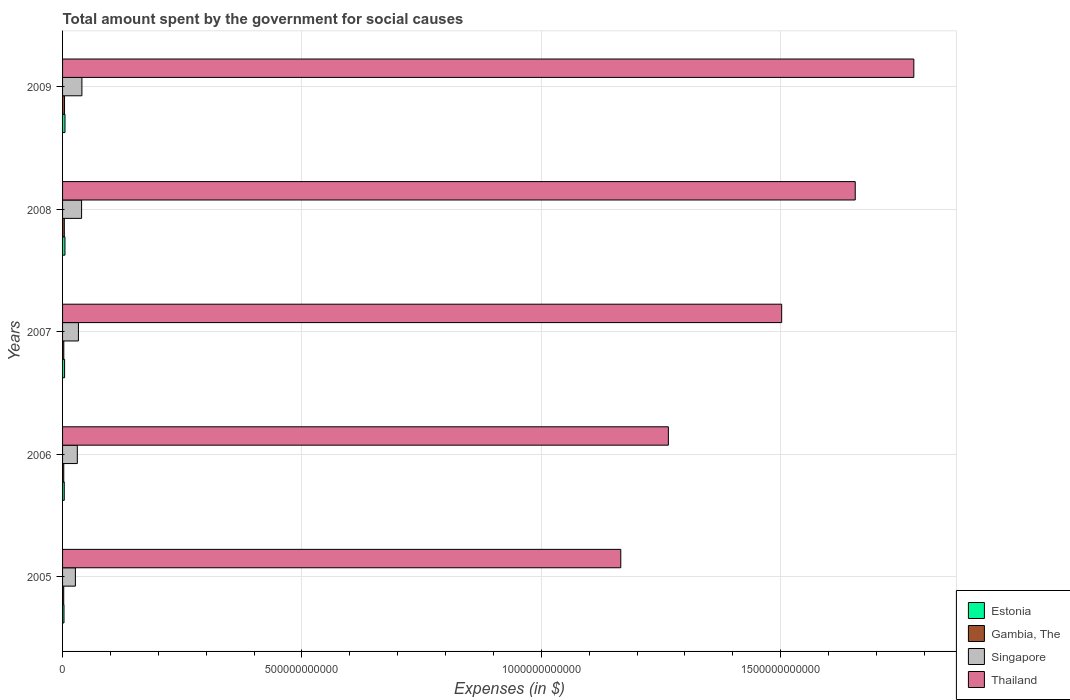How many groups of bars are there?
Ensure brevity in your answer.  5. Are the number of bars per tick equal to the number of legend labels?
Your answer should be compact. Yes. How many bars are there on the 3rd tick from the bottom?
Make the answer very short. 4. What is the label of the 1st group of bars from the top?
Provide a short and direct response. 2009. What is the amount spent for social causes by the government in Thailand in 2005?
Make the answer very short. 1.17e+12. Across all years, what is the maximum amount spent for social causes by the government in Estonia?
Provide a short and direct response. 5.04e+09. Across all years, what is the minimum amount spent for social causes by the government in Singapore?
Your answer should be very brief. 2.68e+1. In which year was the amount spent for social causes by the government in Thailand maximum?
Your answer should be very brief. 2009. In which year was the amount spent for social causes by the government in Estonia minimum?
Provide a short and direct response. 2005. What is the total amount spent for social causes by the government in Thailand in the graph?
Your answer should be compact. 7.37e+12. What is the difference between the amount spent for social causes by the government in Singapore in 2006 and that in 2009?
Ensure brevity in your answer.  -9.56e+09. What is the difference between the amount spent for social causes by the government in Singapore in 2005 and the amount spent for social causes by the government in Thailand in 2008?
Offer a very short reply. -1.63e+12. What is the average amount spent for social causes by the government in Gambia, The per year?
Ensure brevity in your answer.  3.06e+09. In the year 2005, what is the difference between the amount spent for social causes by the government in Singapore and amount spent for social causes by the government in Thailand?
Keep it short and to the point. -1.14e+12. In how many years, is the amount spent for social causes by the government in Singapore greater than 1700000000000 $?
Make the answer very short. 0. What is the ratio of the amount spent for social causes by the government in Singapore in 2008 to that in 2009?
Give a very brief answer. 0.98. What is the difference between the highest and the second highest amount spent for social causes by the government in Thailand?
Provide a short and direct response. 1.22e+11. What is the difference between the highest and the lowest amount spent for social causes by the government in Gambia, The?
Provide a succinct answer. 1.70e+09. In how many years, is the amount spent for social causes by the government in Gambia, The greater than the average amount spent for social causes by the government in Gambia, The taken over all years?
Your answer should be compact. 2. Is it the case that in every year, the sum of the amount spent for social causes by the government in Estonia and amount spent for social causes by the government in Singapore is greater than the sum of amount spent for social causes by the government in Gambia, The and amount spent for social causes by the government in Thailand?
Your response must be concise. No. What does the 1st bar from the top in 2009 represents?
Provide a succinct answer. Thailand. What does the 4th bar from the bottom in 2009 represents?
Ensure brevity in your answer.  Thailand. How many bars are there?
Your answer should be compact. 20. Are all the bars in the graph horizontal?
Ensure brevity in your answer.  Yes. What is the difference between two consecutive major ticks on the X-axis?
Offer a terse response. 5.00e+11. Are the values on the major ticks of X-axis written in scientific E-notation?
Give a very brief answer. No. Does the graph contain grids?
Offer a very short reply. Yes. How many legend labels are there?
Offer a very short reply. 4. How are the legend labels stacked?
Your answer should be very brief. Vertical. What is the title of the graph?
Offer a very short reply. Total amount spent by the government for social causes. What is the label or title of the X-axis?
Give a very brief answer. Expenses (in $). What is the Expenses (in $) of Estonia in 2005?
Provide a short and direct response. 2.99e+09. What is the Expenses (in $) of Gambia, The in 2005?
Offer a terse response. 2.42e+09. What is the Expenses (in $) in Singapore in 2005?
Ensure brevity in your answer.  2.68e+1. What is the Expenses (in $) in Thailand in 2005?
Make the answer very short. 1.17e+12. What is the Expenses (in $) of Estonia in 2006?
Your response must be concise. 3.56e+09. What is the Expenses (in $) in Gambia, The in 2006?
Ensure brevity in your answer.  2.52e+09. What is the Expenses (in $) of Singapore in 2006?
Your answer should be compact. 3.08e+1. What is the Expenses (in $) in Thailand in 2006?
Offer a very short reply. 1.27e+12. What is the Expenses (in $) in Estonia in 2007?
Offer a very short reply. 4.25e+09. What is the Expenses (in $) in Gambia, The in 2007?
Keep it short and to the point. 2.58e+09. What is the Expenses (in $) in Singapore in 2007?
Make the answer very short. 3.31e+1. What is the Expenses (in $) in Thailand in 2007?
Offer a very short reply. 1.50e+12. What is the Expenses (in $) in Estonia in 2008?
Ensure brevity in your answer.  5.00e+09. What is the Expenses (in $) in Gambia, The in 2008?
Offer a terse response. 3.65e+09. What is the Expenses (in $) of Singapore in 2008?
Your answer should be compact. 3.97e+1. What is the Expenses (in $) of Thailand in 2008?
Make the answer very short. 1.66e+12. What is the Expenses (in $) in Estonia in 2009?
Keep it short and to the point. 5.04e+09. What is the Expenses (in $) of Gambia, The in 2009?
Make the answer very short. 4.12e+09. What is the Expenses (in $) in Singapore in 2009?
Give a very brief answer. 4.04e+1. What is the Expenses (in $) in Thailand in 2009?
Your answer should be very brief. 1.78e+12. Across all years, what is the maximum Expenses (in $) in Estonia?
Keep it short and to the point. 5.04e+09. Across all years, what is the maximum Expenses (in $) of Gambia, The?
Offer a terse response. 4.12e+09. Across all years, what is the maximum Expenses (in $) in Singapore?
Your answer should be very brief. 4.04e+1. Across all years, what is the maximum Expenses (in $) of Thailand?
Offer a very short reply. 1.78e+12. Across all years, what is the minimum Expenses (in $) of Estonia?
Your response must be concise. 2.99e+09. Across all years, what is the minimum Expenses (in $) of Gambia, The?
Your answer should be very brief. 2.42e+09. Across all years, what is the minimum Expenses (in $) of Singapore?
Offer a very short reply. 2.68e+1. Across all years, what is the minimum Expenses (in $) of Thailand?
Give a very brief answer. 1.17e+12. What is the total Expenses (in $) of Estonia in the graph?
Ensure brevity in your answer.  2.08e+1. What is the total Expenses (in $) in Gambia, The in the graph?
Provide a succinct answer. 1.53e+1. What is the total Expenses (in $) in Singapore in the graph?
Ensure brevity in your answer.  1.71e+11. What is the total Expenses (in $) in Thailand in the graph?
Provide a succinct answer. 7.37e+12. What is the difference between the Expenses (in $) in Estonia in 2005 and that in 2006?
Your answer should be compact. -5.69e+08. What is the difference between the Expenses (in $) of Gambia, The in 2005 and that in 2006?
Provide a succinct answer. -9.60e+07. What is the difference between the Expenses (in $) in Singapore in 2005 and that in 2006?
Make the answer very short. -4.04e+09. What is the difference between the Expenses (in $) of Thailand in 2005 and that in 2006?
Your answer should be very brief. -9.94e+1. What is the difference between the Expenses (in $) in Estonia in 2005 and that in 2007?
Make the answer very short. -1.26e+09. What is the difference between the Expenses (in $) of Gambia, The in 2005 and that in 2007?
Keep it short and to the point. -1.65e+08. What is the difference between the Expenses (in $) of Singapore in 2005 and that in 2007?
Your answer should be very brief. -6.34e+09. What is the difference between the Expenses (in $) of Thailand in 2005 and that in 2007?
Ensure brevity in your answer.  -3.36e+11. What is the difference between the Expenses (in $) in Estonia in 2005 and that in 2008?
Your answer should be very brief. -2.01e+09. What is the difference between the Expenses (in $) in Gambia, The in 2005 and that in 2008?
Offer a very short reply. -1.23e+09. What is the difference between the Expenses (in $) in Singapore in 2005 and that in 2008?
Provide a succinct answer. -1.29e+1. What is the difference between the Expenses (in $) of Thailand in 2005 and that in 2008?
Make the answer very short. -4.90e+11. What is the difference between the Expenses (in $) in Estonia in 2005 and that in 2009?
Provide a succinct answer. -2.05e+09. What is the difference between the Expenses (in $) in Gambia, The in 2005 and that in 2009?
Offer a terse response. -1.70e+09. What is the difference between the Expenses (in $) of Singapore in 2005 and that in 2009?
Provide a short and direct response. -1.36e+1. What is the difference between the Expenses (in $) of Thailand in 2005 and that in 2009?
Provide a short and direct response. -6.12e+11. What is the difference between the Expenses (in $) of Estonia in 2006 and that in 2007?
Give a very brief answer. -6.92e+08. What is the difference between the Expenses (in $) in Gambia, The in 2006 and that in 2007?
Your answer should be very brief. -6.88e+07. What is the difference between the Expenses (in $) in Singapore in 2006 and that in 2007?
Give a very brief answer. -2.30e+09. What is the difference between the Expenses (in $) of Thailand in 2006 and that in 2007?
Make the answer very short. -2.37e+11. What is the difference between the Expenses (in $) of Estonia in 2006 and that in 2008?
Give a very brief answer. -1.44e+09. What is the difference between the Expenses (in $) in Gambia, The in 2006 and that in 2008?
Give a very brief answer. -1.13e+09. What is the difference between the Expenses (in $) of Singapore in 2006 and that in 2008?
Your response must be concise. -8.90e+09. What is the difference between the Expenses (in $) of Thailand in 2006 and that in 2008?
Provide a succinct answer. -3.90e+11. What is the difference between the Expenses (in $) in Estonia in 2006 and that in 2009?
Your response must be concise. -1.48e+09. What is the difference between the Expenses (in $) in Gambia, The in 2006 and that in 2009?
Your answer should be compact. -1.60e+09. What is the difference between the Expenses (in $) of Singapore in 2006 and that in 2009?
Your answer should be compact. -9.56e+09. What is the difference between the Expenses (in $) of Thailand in 2006 and that in 2009?
Ensure brevity in your answer.  -5.13e+11. What is the difference between the Expenses (in $) of Estonia in 2007 and that in 2008?
Give a very brief answer. -7.51e+08. What is the difference between the Expenses (in $) in Gambia, The in 2007 and that in 2008?
Provide a succinct answer. -1.07e+09. What is the difference between the Expenses (in $) of Singapore in 2007 and that in 2008?
Keep it short and to the point. -6.60e+09. What is the difference between the Expenses (in $) of Thailand in 2007 and that in 2008?
Offer a terse response. -1.54e+11. What is the difference between the Expenses (in $) in Estonia in 2007 and that in 2009?
Give a very brief answer. -7.90e+08. What is the difference between the Expenses (in $) of Gambia, The in 2007 and that in 2009?
Your answer should be very brief. -1.53e+09. What is the difference between the Expenses (in $) of Singapore in 2007 and that in 2009?
Provide a succinct answer. -7.26e+09. What is the difference between the Expenses (in $) of Thailand in 2007 and that in 2009?
Offer a very short reply. -2.76e+11. What is the difference between the Expenses (in $) of Estonia in 2008 and that in 2009?
Offer a very short reply. -3.87e+07. What is the difference between the Expenses (in $) of Gambia, The in 2008 and that in 2009?
Ensure brevity in your answer.  -4.65e+08. What is the difference between the Expenses (in $) of Singapore in 2008 and that in 2009?
Give a very brief answer. -6.59e+08. What is the difference between the Expenses (in $) in Thailand in 2008 and that in 2009?
Your response must be concise. -1.22e+11. What is the difference between the Expenses (in $) in Estonia in 2005 and the Expenses (in $) in Gambia, The in 2006?
Make the answer very short. 4.75e+08. What is the difference between the Expenses (in $) of Estonia in 2005 and the Expenses (in $) of Singapore in 2006?
Your response must be concise. -2.78e+1. What is the difference between the Expenses (in $) of Estonia in 2005 and the Expenses (in $) of Thailand in 2006?
Give a very brief answer. -1.26e+12. What is the difference between the Expenses (in $) in Gambia, The in 2005 and the Expenses (in $) in Singapore in 2006?
Offer a very short reply. -2.84e+1. What is the difference between the Expenses (in $) of Gambia, The in 2005 and the Expenses (in $) of Thailand in 2006?
Your answer should be compact. -1.26e+12. What is the difference between the Expenses (in $) in Singapore in 2005 and the Expenses (in $) in Thailand in 2006?
Provide a succinct answer. -1.24e+12. What is the difference between the Expenses (in $) in Estonia in 2005 and the Expenses (in $) in Gambia, The in 2007?
Your response must be concise. 4.06e+08. What is the difference between the Expenses (in $) of Estonia in 2005 and the Expenses (in $) of Singapore in 2007?
Provide a short and direct response. -3.01e+1. What is the difference between the Expenses (in $) of Estonia in 2005 and the Expenses (in $) of Thailand in 2007?
Make the answer very short. -1.50e+12. What is the difference between the Expenses (in $) of Gambia, The in 2005 and the Expenses (in $) of Singapore in 2007?
Offer a very short reply. -3.07e+1. What is the difference between the Expenses (in $) in Gambia, The in 2005 and the Expenses (in $) in Thailand in 2007?
Make the answer very short. -1.50e+12. What is the difference between the Expenses (in $) in Singapore in 2005 and the Expenses (in $) in Thailand in 2007?
Provide a succinct answer. -1.48e+12. What is the difference between the Expenses (in $) in Estonia in 2005 and the Expenses (in $) in Gambia, The in 2008?
Your response must be concise. -6.60e+08. What is the difference between the Expenses (in $) in Estonia in 2005 and the Expenses (in $) in Singapore in 2008?
Make the answer very short. -3.67e+1. What is the difference between the Expenses (in $) of Estonia in 2005 and the Expenses (in $) of Thailand in 2008?
Provide a succinct answer. -1.65e+12. What is the difference between the Expenses (in $) in Gambia, The in 2005 and the Expenses (in $) in Singapore in 2008?
Provide a short and direct response. -3.73e+1. What is the difference between the Expenses (in $) of Gambia, The in 2005 and the Expenses (in $) of Thailand in 2008?
Your response must be concise. -1.65e+12. What is the difference between the Expenses (in $) in Singapore in 2005 and the Expenses (in $) in Thailand in 2008?
Your answer should be very brief. -1.63e+12. What is the difference between the Expenses (in $) in Estonia in 2005 and the Expenses (in $) in Gambia, The in 2009?
Make the answer very short. -1.12e+09. What is the difference between the Expenses (in $) in Estonia in 2005 and the Expenses (in $) in Singapore in 2009?
Your response must be concise. -3.74e+1. What is the difference between the Expenses (in $) of Estonia in 2005 and the Expenses (in $) of Thailand in 2009?
Make the answer very short. -1.78e+12. What is the difference between the Expenses (in $) of Gambia, The in 2005 and the Expenses (in $) of Singapore in 2009?
Your answer should be very brief. -3.80e+1. What is the difference between the Expenses (in $) in Gambia, The in 2005 and the Expenses (in $) in Thailand in 2009?
Offer a very short reply. -1.78e+12. What is the difference between the Expenses (in $) of Singapore in 2005 and the Expenses (in $) of Thailand in 2009?
Provide a short and direct response. -1.75e+12. What is the difference between the Expenses (in $) of Estonia in 2006 and the Expenses (in $) of Gambia, The in 2007?
Make the answer very short. 9.75e+08. What is the difference between the Expenses (in $) in Estonia in 2006 and the Expenses (in $) in Singapore in 2007?
Keep it short and to the point. -2.96e+1. What is the difference between the Expenses (in $) in Estonia in 2006 and the Expenses (in $) in Thailand in 2007?
Keep it short and to the point. -1.50e+12. What is the difference between the Expenses (in $) in Gambia, The in 2006 and the Expenses (in $) in Singapore in 2007?
Your answer should be compact. -3.06e+1. What is the difference between the Expenses (in $) of Gambia, The in 2006 and the Expenses (in $) of Thailand in 2007?
Make the answer very short. -1.50e+12. What is the difference between the Expenses (in $) of Singapore in 2006 and the Expenses (in $) of Thailand in 2007?
Offer a very short reply. -1.47e+12. What is the difference between the Expenses (in $) of Estonia in 2006 and the Expenses (in $) of Gambia, The in 2008?
Your answer should be compact. -9.08e+07. What is the difference between the Expenses (in $) of Estonia in 2006 and the Expenses (in $) of Singapore in 2008?
Keep it short and to the point. -3.62e+1. What is the difference between the Expenses (in $) of Estonia in 2006 and the Expenses (in $) of Thailand in 2008?
Your answer should be compact. -1.65e+12. What is the difference between the Expenses (in $) of Gambia, The in 2006 and the Expenses (in $) of Singapore in 2008?
Offer a terse response. -3.72e+1. What is the difference between the Expenses (in $) in Gambia, The in 2006 and the Expenses (in $) in Thailand in 2008?
Your answer should be compact. -1.65e+12. What is the difference between the Expenses (in $) in Singapore in 2006 and the Expenses (in $) in Thailand in 2008?
Offer a very short reply. -1.63e+12. What is the difference between the Expenses (in $) in Estonia in 2006 and the Expenses (in $) in Gambia, The in 2009?
Provide a succinct answer. -5.56e+08. What is the difference between the Expenses (in $) in Estonia in 2006 and the Expenses (in $) in Singapore in 2009?
Provide a short and direct response. -3.68e+1. What is the difference between the Expenses (in $) of Estonia in 2006 and the Expenses (in $) of Thailand in 2009?
Offer a terse response. -1.77e+12. What is the difference between the Expenses (in $) of Gambia, The in 2006 and the Expenses (in $) of Singapore in 2009?
Give a very brief answer. -3.79e+1. What is the difference between the Expenses (in $) of Gambia, The in 2006 and the Expenses (in $) of Thailand in 2009?
Offer a terse response. -1.78e+12. What is the difference between the Expenses (in $) of Singapore in 2006 and the Expenses (in $) of Thailand in 2009?
Your answer should be compact. -1.75e+12. What is the difference between the Expenses (in $) in Estonia in 2007 and the Expenses (in $) in Gambia, The in 2008?
Make the answer very short. 6.01e+08. What is the difference between the Expenses (in $) of Estonia in 2007 and the Expenses (in $) of Singapore in 2008?
Your answer should be very brief. -3.55e+1. What is the difference between the Expenses (in $) of Estonia in 2007 and the Expenses (in $) of Thailand in 2008?
Provide a short and direct response. -1.65e+12. What is the difference between the Expenses (in $) in Gambia, The in 2007 and the Expenses (in $) in Singapore in 2008?
Offer a very short reply. -3.72e+1. What is the difference between the Expenses (in $) in Gambia, The in 2007 and the Expenses (in $) in Thailand in 2008?
Make the answer very short. -1.65e+12. What is the difference between the Expenses (in $) in Singapore in 2007 and the Expenses (in $) in Thailand in 2008?
Provide a succinct answer. -1.62e+12. What is the difference between the Expenses (in $) of Estonia in 2007 and the Expenses (in $) of Gambia, The in 2009?
Ensure brevity in your answer.  1.36e+08. What is the difference between the Expenses (in $) in Estonia in 2007 and the Expenses (in $) in Singapore in 2009?
Your answer should be compact. -3.61e+1. What is the difference between the Expenses (in $) in Estonia in 2007 and the Expenses (in $) in Thailand in 2009?
Your response must be concise. -1.77e+12. What is the difference between the Expenses (in $) of Gambia, The in 2007 and the Expenses (in $) of Singapore in 2009?
Keep it short and to the point. -3.78e+1. What is the difference between the Expenses (in $) of Gambia, The in 2007 and the Expenses (in $) of Thailand in 2009?
Your answer should be compact. -1.78e+12. What is the difference between the Expenses (in $) of Singapore in 2007 and the Expenses (in $) of Thailand in 2009?
Provide a short and direct response. -1.75e+12. What is the difference between the Expenses (in $) of Estonia in 2008 and the Expenses (in $) of Gambia, The in 2009?
Your response must be concise. 8.87e+08. What is the difference between the Expenses (in $) of Estonia in 2008 and the Expenses (in $) of Singapore in 2009?
Offer a very short reply. -3.54e+1. What is the difference between the Expenses (in $) in Estonia in 2008 and the Expenses (in $) in Thailand in 2009?
Your answer should be very brief. -1.77e+12. What is the difference between the Expenses (in $) in Gambia, The in 2008 and the Expenses (in $) in Singapore in 2009?
Your response must be concise. -3.67e+1. What is the difference between the Expenses (in $) in Gambia, The in 2008 and the Expenses (in $) in Thailand in 2009?
Ensure brevity in your answer.  -1.77e+12. What is the difference between the Expenses (in $) of Singapore in 2008 and the Expenses (in $) of Thailand in 2009?
Ensure brevity in your answer.  -1.74e+12. What is the average Expenses (in $) in Estonia per year?
Your response must be concise. 4.17e+09. What is the average Expenses (in $) of Gambia, The per year?
Offer a very short reply. 3.06e+09. What is the average Expenses (in $) in Singapore per year?
Provide a succinct answer. 3.42e+1. What is the average Expenses (in $) of Thailand per year?
Offer a very short reply. 1.47e+12. In the year 2005, what is the difference between the Expenses (in $) of Estonia and Expenses (in $) of Gambia, The?
Your answer should be very brief. 5.71e+08. In the year 2005, what is the difference between the Expenses (in $) of Estonia and Expenses (in $) of Singapore?
Give a very brief answer. -2.38e+1. In the year 2005, what is the difference between the Expenses (in $) of Estonia and Expenses (in $) of Thailand?
Give a very brief answer. -1.16e+12. In the year 2005, what is the difference between the Expenses (in $) of Gambia, The and Expenses (in $) of Singapore?
Offer a very short reply. -2.44e+1. In the year 2005, what is the difference between the Expenses (in $) of Gambia, The and Expenses (in $) of Thailand?
Ensure brevity in your answer.  -1.16e+12. In the year 2005, what is the difference between the Expenses (in $) of Singapore and Expenses (in $) of Thailand?
Your answer should be compact. -1.14e+12. In the year 2006, what is the difference between the Expenses (in $) of Estonia and Expenses (in $) of Gambia, The?
Your answer should be compact. 1.04e+09. In the year 2006, what is the difference between the Expenses (in $) in Estonia and Expenses (in $) in Singapore?
Offer a very short reply. -2.73e+1. In the year 2006, what is the difference between the Expenses (in $) in Estonia and Expenses (in $) in Thailand?
Keep it short and to the point. -1.26e+12. In the year 2006, what is the difference between the Expenses (in $) in Gambia, The and Expenses (in $) in Singapore?
Provide a short and direct response. -2.83e+1. In the year 2006, what is the difference between the Expenses (in $) in Gambia, The and Expenses (in $) in Thailand?
Give a very brief answer. -1.26e+12. In the year 2006, what is the difference between the Expenses (in $) of Singapore and Expenses (in $) of Thailand?
Provide a succinct answer. -1.23e+12. In the year 2007, what is the difference between the Expenses (in $) of Estonia and Expenses (in $) of Gambia, The?
Ensure brevity in your answer.  1.67e+09. In the year 2007, what is the difference between the Expenses (in $) in Estonia and Expenses (in $) in Singapore?
Your response must be concise. -2.89e+1. In the year 2007, what is the difference between the Expenses (in $) of Estonia and Expenses (in $) of Thailand?
Provide a short and direct response. -1.50e+12. In the year 2007, what is the difference between the Expenses (in $) of Gambia, The and Expenses (in $) of Singapore?
Provide a short and direct response. -3.05e+1. In the year 2007, what is the difference between the Expenses (in $) in Gambia, The and Expenses (in $) in Thailand?
Keep it short and to the point. -1.50e+12. In the year 2007, what is the difference between the Expenses (in $) in Singapore and Expenses (in $) in Thailand?
Give a very brief answer. -1.47e+12. In the year 2008, what is the difference between the Expenses (in $) in Estonia and Expenses (in $) in Gambia, The?
Give a very brief answer. 1.35e+09. In the year 2008, what is the difference between the Expenses (in $) of Estonia and Expenses (in $) of Singapore?
Offer a very short reply. -3.47e+1. In the year 2008, what is the difference between the Expenses (in $) of Estonia and Expenses (in $) of Thailand?
Offer a very short reply. -1.65e+12. In the year 2008, what is the difference between the Expenses (in $) of Gambia, The and Expenses (in $) of Singapore?
Ensure brevity in your answer.  -3.61e+1. In the year 2008, what is the difference between the Expenses (in $) in Gambia, The and Expenses (in $) in Thailand?
Your response must be concise. -1.65e+12. In the year 2008, what is the difference between the Expenses (in $) of Singapore and Expenses (in $) of Thailand?
Keep it short and to the point. -1.62e+12. In the year 2009, what is the difference between the Expenses (in $) of Estonia and Expenses (in $) of Gambia, The?
Ensure brevity in your answer.  9.26e+08. In the year 2009, what is the difference between the Expenses (in $) in Estonia and Expenses (in $) in Singapore?
Provide a succinct answer. -3.54e+1. In the year 2009, what is the difference between the Expenses (in $) of Estonia and Expenses (in $) of Thailand?
Offer a very short reply. -1.77e+12. In the year 2009, what is the difference between the Expenses (in $) of Gambia, The and Expenses (in $) of Singapore?
Your response must be concise. -3.63e+1. In the year 2009, what is the difference between the Expenses (in $) in Gambia, The and Expenses (in $) in Thailand?
Ensure brevity in your answer.  -1.77e+12. In the year 2009, what is the difference between the Expenses (in $) of Singapore and Expenses (in $) of Thailand?
Make the answer very short. -1.74e+12. What is the ratio of the Expenses (in $) in Estonia in 2005 to that in 2006?
Ensure brevity in your answer.  0.84. What is the ratio of the Expenses (in $) in Gambia, The in 2005 to that in 2006?
Provide a short and direct response. 0.96. What is the ratio of the Expenses (in $) of Singapore in 2005 to that in 2006?
Give a very brief answer. 0.87. What is the ratio of the Expenses (in $) in Thailand in 2005 to that in 2006?
Make the answer very short. 0.92. What is the ratio of the Expenses (in $) of Estonia in 2005 to that in 2007?
Your answer should be compact. 0.7. What is the ratio of the Expenses (in $) of Gambia, The in 2005 to that in 2007?
Provide a short and direct response. 0.94. What is the ratio of the Expenses (in $) of Singapore in 2005 to that in 2007?
Your answer should be very brief. 0.81. What is the ratio of the Expenses (in $) in Thailand in 2005 to that in 2007?
Ensure brevity in your answer.  0.78. What is the ratio of the Expenses (in $) in Estonia in 2005 to that in 2008?
Offer a terse response. 0.6. What is the ratio of the Expenses (in $) of Gambia, The in 2005 to that in 2008?
Your response must be concise. 0.66. What is the ratio of the Expenses (in $) of Singapore in 2005 to that in 2008?
Ensure brevity in your answer.  0.67. What is the ratio of the Expenses (in $) in Thailand in 2005 to that in 2008?
Offer a very short reply. 0.7. What is the ratio of the Expenses (in $) of Estonia in 2005 to that in 2009?
Offer a very short reply. 0.59. What is the ratio of the Expenses (in $) of Gambia, The in 2005 to that in 2009?
Offer a very short reply. 0.59. What is the ratio of the Expenses (in $) of Singapore in 2005 to that in 2009?
Your answer should be compact. 0.66. What is the ratio of the Expenses (in $) of Thailand in 2005 to that in 2009?
Offer a terse response. 0.66. What is the ratio of the Expenses (in $) of Estonia in 2006 to that in 2007?
Offer a very short reply. 0.84. What is the ratio of the Expenses (in $) in Gambia, The in 2006 to that in 2007?
Your answer should be compact. 0.97. What is the ratio of the Expenses (in $) in Singapore in 2006 to that in 2007?
Give a very brief answer. 0.93. What is the ratio of the Expenses (in $) in Thailand in 2006 to that in 2007?
Offer a very short reply. 0.84. What is the ratio of the Expenses (in $) in Estonia in 2006 to that in 2008?
Offer a terse response. 0.71. What is the ratio of the Expenses (in $) in Gambia, The in 2006 to that in 2008?
Ensure brevity in your answer.  0.69. What is the ratio of the Expenses (in $) in Singapore in 2006 to that in 2008?
Offer a very short reply. 0.78. What is the ratio of the Expenses (in $) of Thailand in 2006 to that in 2008?
Your answer should be compact. 0.76. What is the ratio of the Expenses (in $) of Estonia in 2006 to that in 2009?
Make the answer very short. 0.71. What is the ratio of the Expenses (in $) of Gambia, The in 2006 to that in 2009?
Provide a short and direct response. 0.61. What is the ratio of the Expenses (in $) of Singapore in 2006 to that in 2009?
Provide a succinct answer. 0.76. What is the ratio of the Expenses (in $) of Thailand in 2006 to that in 2009?
Ensure brevity in your answer.  0.71. What is the ratio of the Expenses (in $) of Estonia in 2007 to that in 2008?
Give a very brief answer. 0.85. What is the ratio of the Expenses (in $) of Gambia, The in 2007 to that in 2008?
Give a very brief answer. 0.71. What is the ratio of the Expenses (in $) of Singapore in 2007 to that in 2008?
Give a very brief answer. 0.83. What is the ratio of the Expenses (in $) of Thailand in 2007 to that in 2008?
Provide a succinct answer. 0.91. What is the ratio of the Expenses (in $) of Estonia in 2007 to that in 2009?
Your answer should be compact. 0.84. What is the ratio of the Expenses (in $) in Gambia, The in 2007 to that in 2009?
Your answer should be compact. 0.63. What is the ratio of the Expenses (in $) of Singapore in 2007 to that in 2009?
Keep it short and to the point. 0.82. What is the ratio of the Expenses (in $) of Thailand in 2007 to that in 2009?
Make the answer very short. 0.84. What is the ratio of the Expenses (in $) in Gambia, The in 2008 to that in 2009?
Your answer should be compact. 0.89. What is the ratio of the Expenses (in $) of Singapore in 2008 to that in 2009?
Your answer should be compact. 0.98. What is the ratio of the Expenses (in $) of Thailand in 2008 to that in 2009?
Your answer should be very brief. 0.93. What is the difference between the highest and the second highest Expenses (in $) in Estonia?
Provide a succinct answer. 3.87e+07. What is the difference between the highest and the second highest Expenses (in $) in Gambia, The?
Offer a very short reply. 4.65e+08. What is the difference between the highest and the second highest Expenses (in $) in Singapore?
Give a very brief answer. 6.59e+08. What is the difference between the highest and the second highest Expenses (in $) in Thailand?
Offer a very short reply. 1.22e+11. What is the difference between the highest and the lowest Expenses (in $) in Estonia?
Your response must be concise. 2.05e+09. What is the difference between the highest and the lowest Expenses (in $) in Gambia, The?
Your response must be concise. 1.70e+09. What is the difference between the highest and the lowest Expenses (in $) in Singapore?
Provide a succinct answer. 1.36e+1. What is the difference between the highest and the lowest Expenses (in $) in Thailand?
Your answer should be compact. 6.12e+11. 